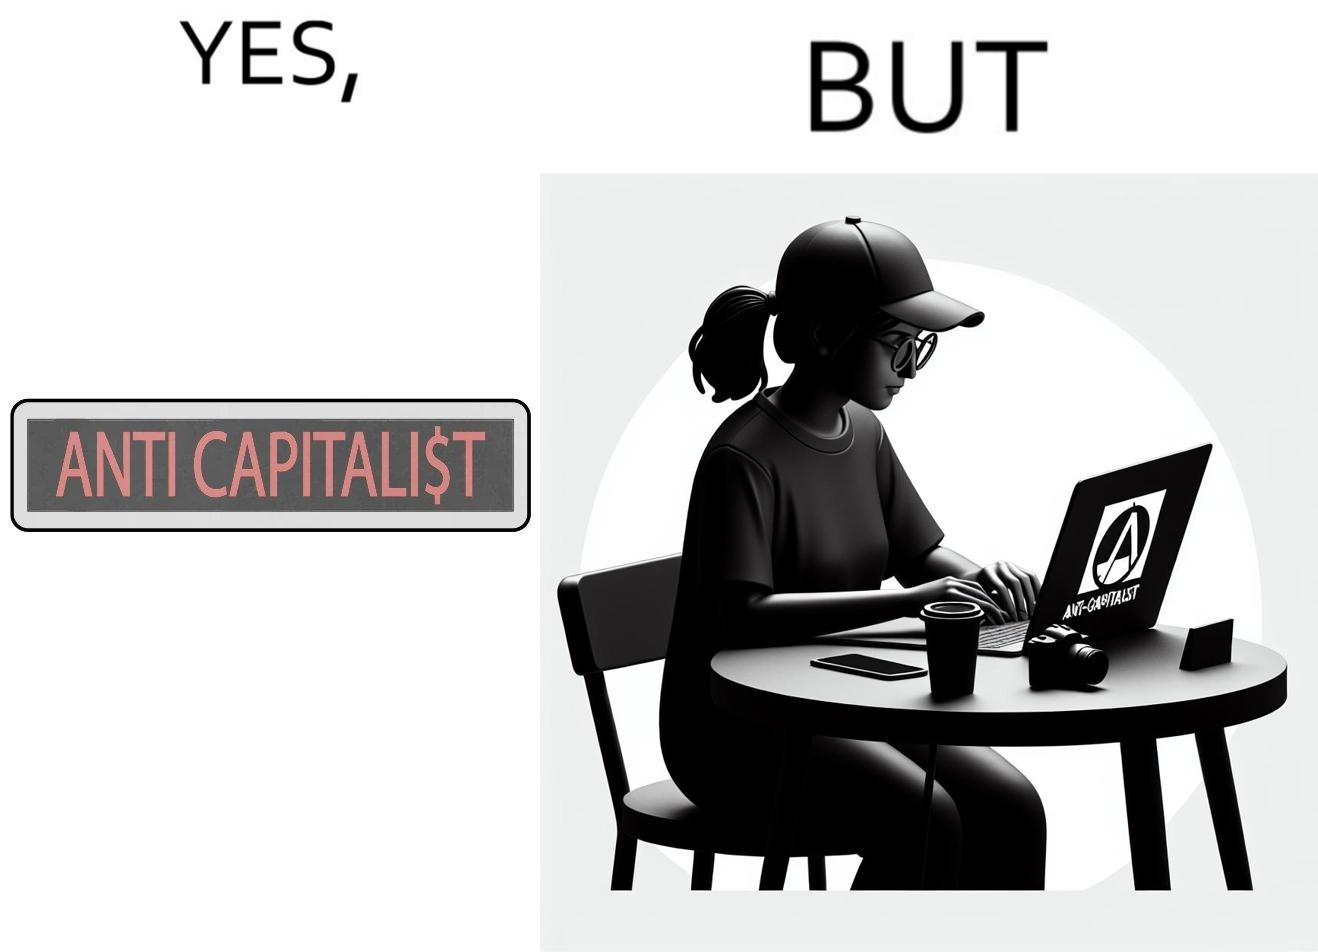Why is this image considered satirical? The overall image is ironical because the people who claim to be anticapitalist are the ones with a lot of capital as shown here. While the woman supports anticapitalism as shown by the sticker on the back of her laptop, she has a phone, a camera and a laptop all of which require money. 